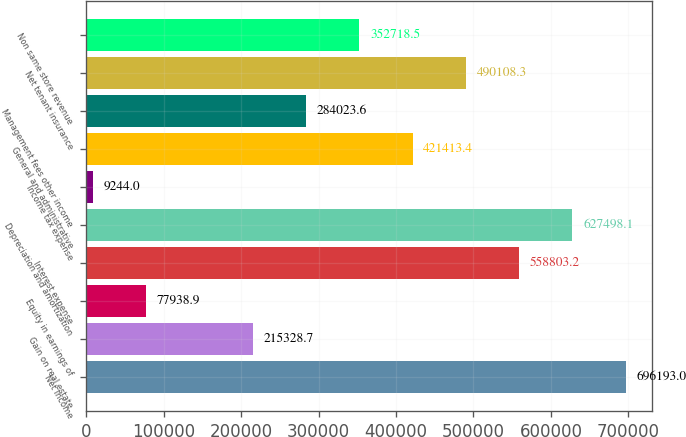Convert chart. <chart><loc_0><loc_0><loc_500><loc_500><bar_chart><fcel>Net Income<fcel>Gain on real estate<fcel>Equity in earnings of<fcel>Interest expense<fcel>Depreciation and amortization<fcel>Income tax expense<fcel>General and administrative<fcel>Management fees other income<fcel>Net tenant insurance<fcel>Non same store revenue<nl><fcel>696193<fcel>215329<fcel>77938.9<fcel>558803<fcel>627498<fcel>9244<fcel>421413<fcel>284024<fcel>490108<fcel>352718<nl></chart> 